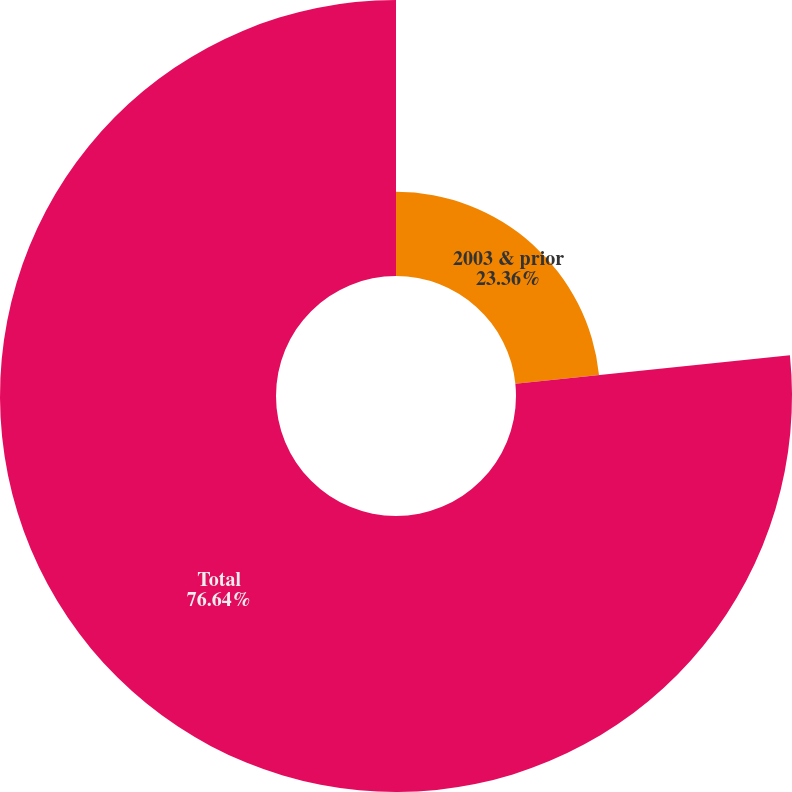Convert chart. <chart><loc_0><loc_0><loc_500><loc_500><pie_chart><fcel>2003 & prior<fcel>Total<nl><fcel>23.36%<fcel>76.64%<nl></chart> 